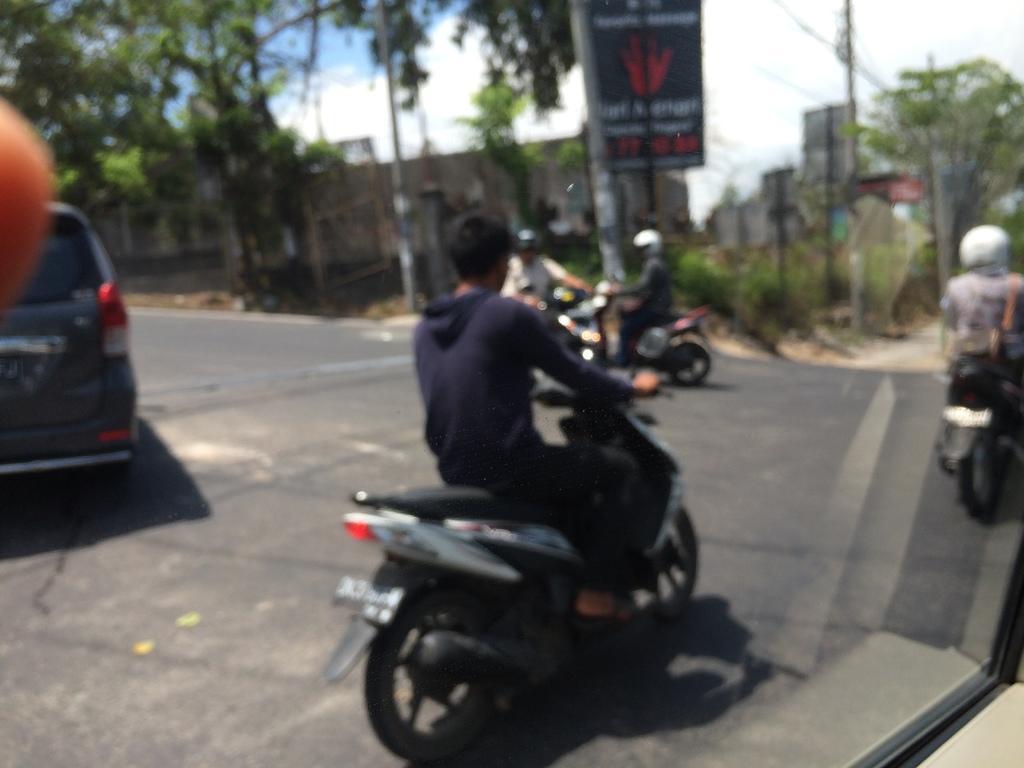In one or two sentences, can you explain what this image depicts? In this image, there is a glass and through the glass, we can see vehicles and people on the road and in the background, there are trees, poles, boards and buildings. 